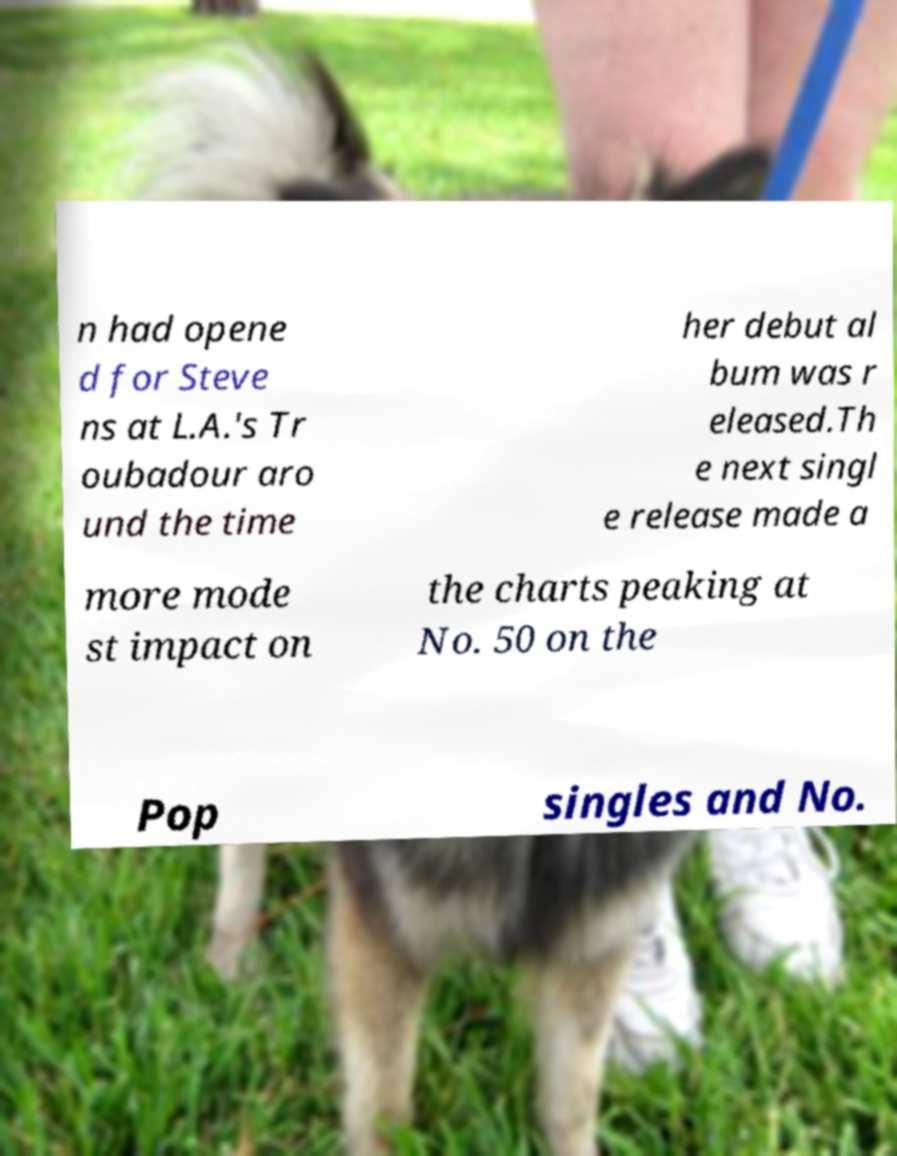Could you extract and type out the text from this image? n had opene d for Steve ns at L.A.'s Tr oubadour aro und the time her debut al bum was r eleased.Th e next singl e release made a more mode st impact on the charts peaking at No. 50 on the Pop singles and No. 